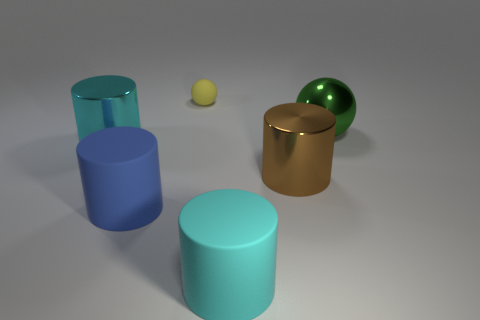What colors do the objects in the image feature? The objects include a range of colors: there's a blue cylinder, a teal cylinder, a cyan cylinder, a brown cylinder, a green sphere, and a small yellow sphere. 